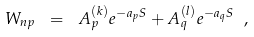<formula> <loc_0><loc_0><loc_500><loc_500>W _ { n p } \ = \ A _ { p } ^ { ( k ) } e ^ { - { a _ { p } S } } + A _ { q } ^ { ( l ) } e ^ { - { a _ { q } S } } \ ,</formula> 